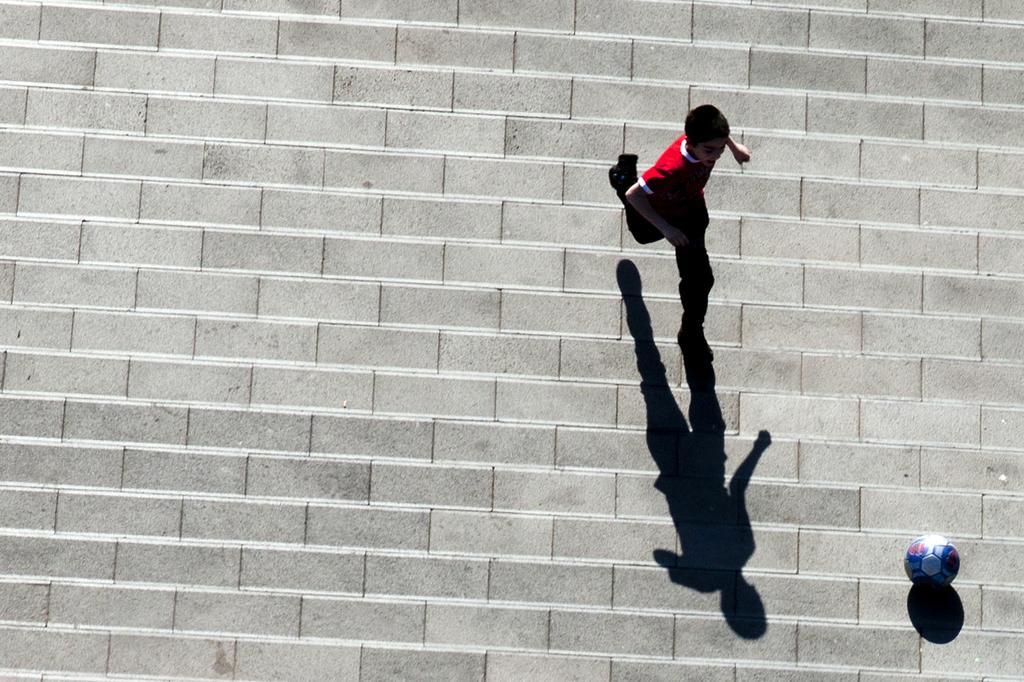In one or two sentences, can you explain what this image depicts? This is a top view of a picture where we can see a child wearing a red color dress is running on the ground. Here we can see a ball and we can see the shadow of the child. 